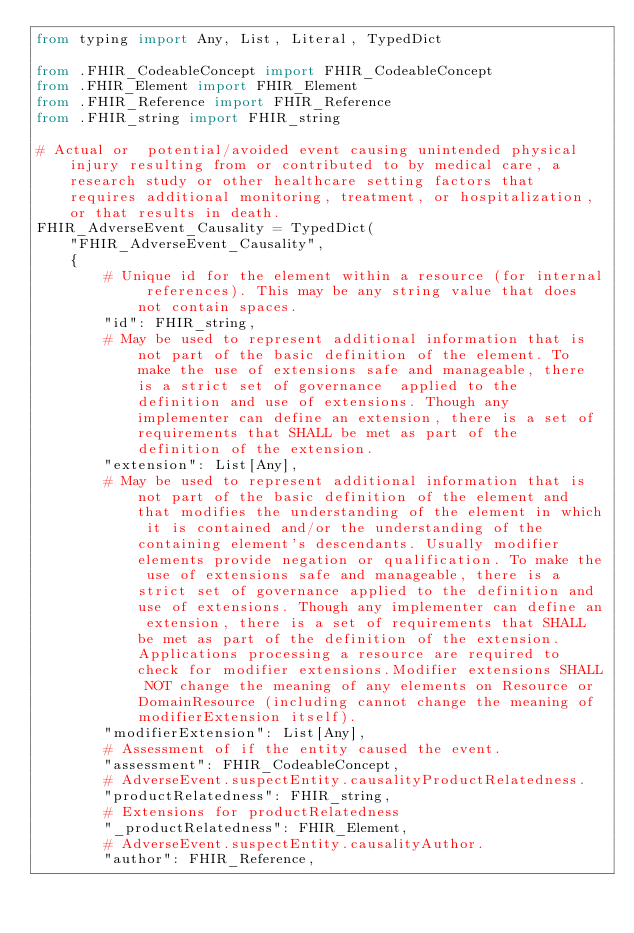<code> <loc_0><loc_0><loc_500><loc_500><_Python_>from typing import Any, List, Literal, TypedDict

from .FHIR_CodeableConcept import FHIR_CodeableConcept
from .FHIR_Element import FHIR_Element
from .FHIR_Reference import FHIR_Reference
from .FHIR_string import FHIR_string

# Actual or  potential/avoided event causing unintended physical injury resulting from or contributed to by medical care, a research study or other healthcare setting factors that requires additional monitoring, treatment, or hospitalization, or that results in death.
FHIR_AdverseEvent_Causality = TypedDict(
    "FHIR_AdverseEvent_Causality",
    {
        # Unique id for the element within a resource (for internal references). This may be any string value that does not contain spaces.
        "id": FHIR_string,
        # May be used to represent additional information that is not part of the basic definition of the element. To make the use of extensions safe and manageable, there is a strict set of governance  applied to the definition and use of extensions. Though any implementer can define an extension, there is a set of requirements that SHALL be met as part of the definition of the extension.
        "extension": List[Any],
        # May be used to represent additional information that is not part of the basic definition of the element and that modifies the understanding of the element in which it is contained and/or the understanding of the containing element's descendants. Usually modifier elements provide negation or qualification. To make the use of extensions safe and manageable, there is a strict set of governance applied to the definition and use of extensions. Though any implementer can define an extension, there is a set of requirements that SHALL be met as part of the definition of the extension. Applications processing a resource are required to check for modifier extensions.Modifier extensions SHALL NOT change the meaning of any elements on Resource or DomainResource (including cannot change the meaning of modifierExtension itself).
        "modifierExtension": List[Any],
        # Assessment of if the entity caused the event.
        "assessment": FHIR_CodeableConcept,
        # AdverseEvent.suspectEntity.causalityProductRelatedness.
        "productRelatedness": FHIR_string,
        # Extensions for productRelatedness
        "_productRelatedness": FHIR_Element,
        # AdverseEvent.suspectEntity.causalityAuthor.
        "author": FHIR_Reference,</code> 